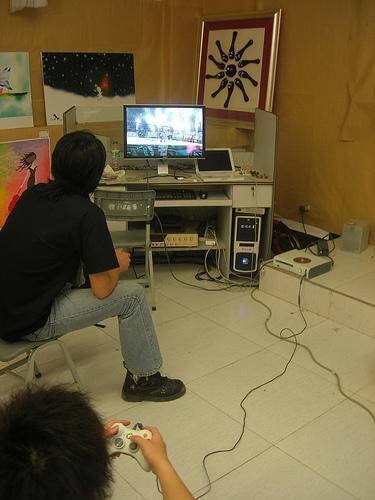How many boys are playing?
Give a very brief answer. 2. 